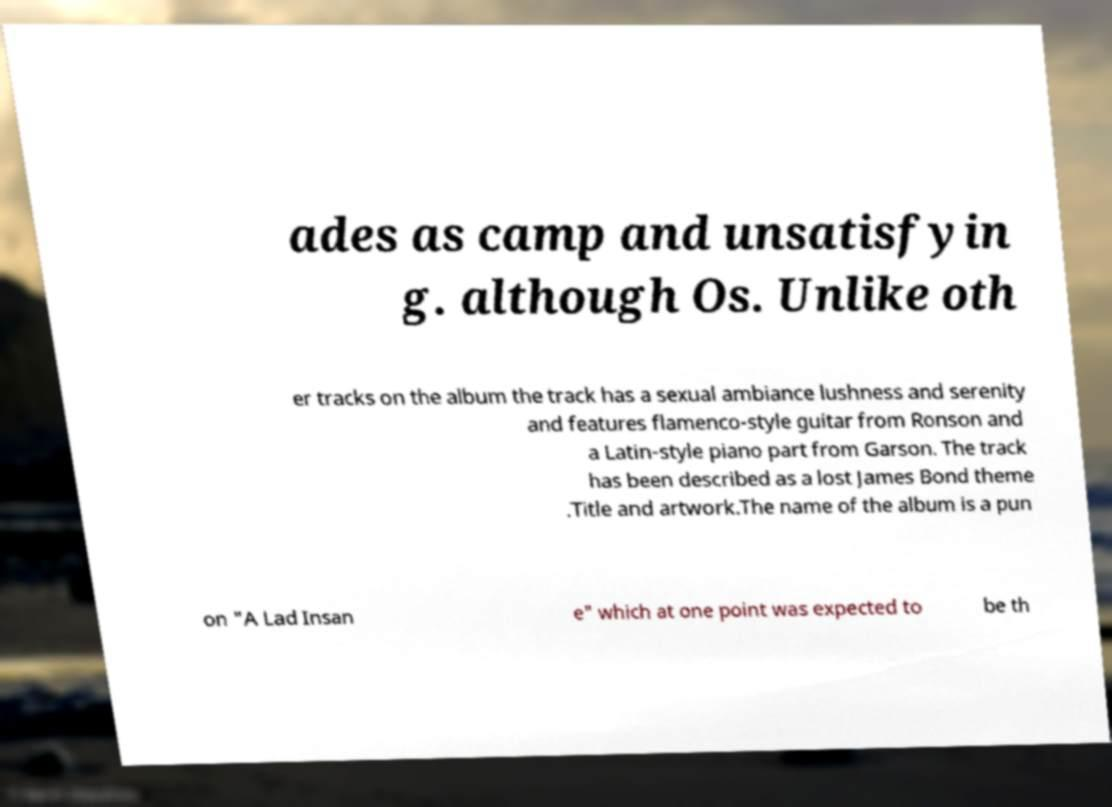I need the written content from this picture converted into text. Can you do that? ades as camp and unsatisfyin g. although Os. Unlike oth er tracks on the album the track has a sexual ambiance lushness and serenity and features flamenco-style guitar from Ronson and a Latin-style piano part from Garson. The track has been described as a lost James Bond theme .Title and artwork.The name of the album is a pun on "A Lad Insan e" which at one point was expected to be th 